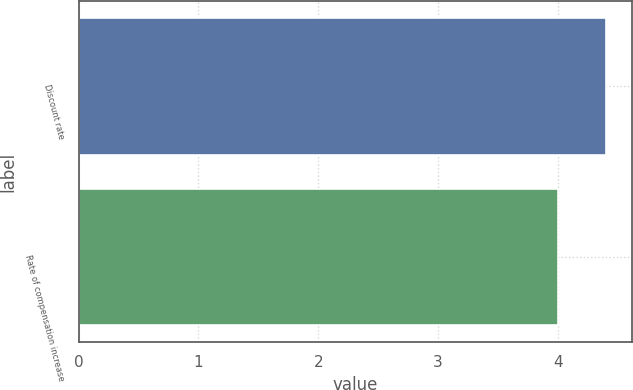Convert chart. <chart><loc_0><loc_0><loc_500><loc_500><bar_chart><fcel>Discount rate<fcel>Rate of compensation increase<nl><fcel>4.4<fcel>4<nl></chart> 